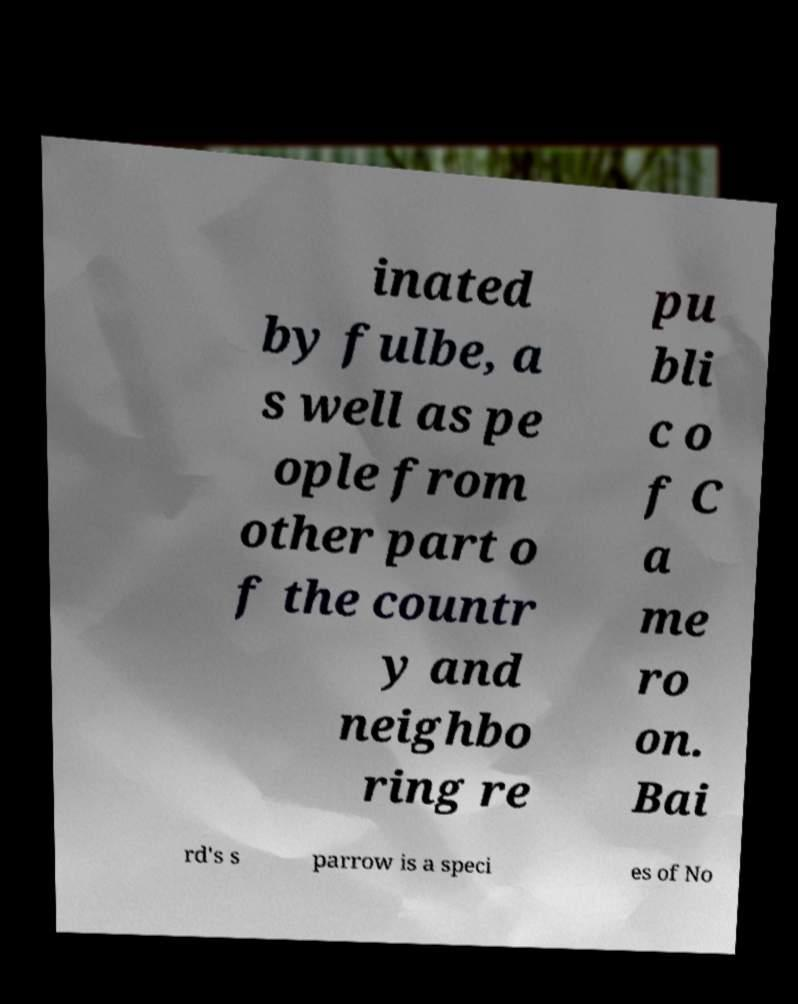What messages or text are displayed in this image? I need them in a readable, typed format. inated by fulbe, a s well as pe ople from other part o f the countr y and neighbo ring re pu bli c o f C a me ro on. Bai rd's s parrow is a speci es of No 